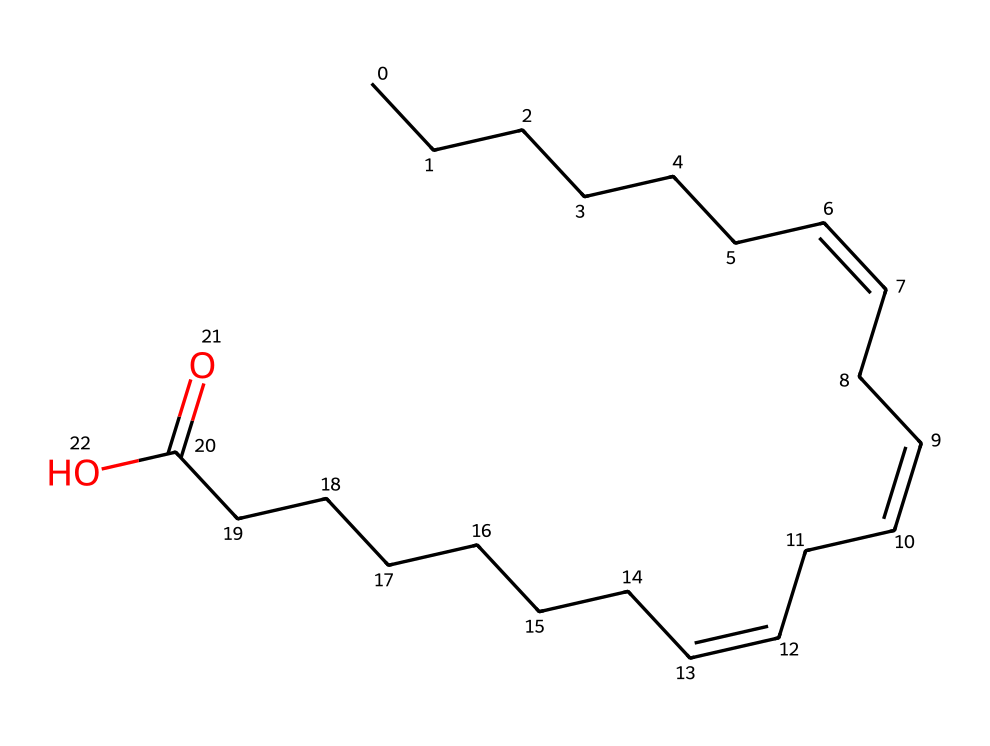how many carbon atoms are in this structure? By examining the SMILES representation, we count the number of carbon (C) atoms explicitly shown, including both the linear chain and any branching. The representation contains a total of 18 carbon atoms.
Answer: 18 how many double bonds are present? In the SMILES string, we identify the locations of double bonds which are indicated by the "/C=C\" segments. By analyzing the structure, we see there are three double bonds in the molecule.
Answer: 3 what is the functional group present in this compound? The presence of the -COOH group at the end of the structure signifies a carboxylic acid functional group. This can be identified from the "CCCCCCC(=O)O" portion of the SMILES, showing both a carbonyl (C=O) and hydroxyl (O-H) group.
Answer: carboxylic acid is this a saturated or unsaturated fatty acid? The presence of multiple carbon-carbon double bonds indicates that the fatty acid is unsaturated. The double bonds create kinks in the molecule, preventing tight packing, which is characteristic of unsaturated fatty acids.
Answer: unsaturated what type of isomerism can occur in this compound? Given the double bonds present in the structure, cis-trans isomerism (geometric isomerism) can occur due to the spatial arrangements possible around these double bonds, distinguishing between cis (same side) and trans (opposite side) configurations.
Answer: cis-trans isomerism how does the presence of double bonds affect the melting point of this compound? The presence of double bonds in the structure introduces kinks that prevent the molecules from packing closely together, which generally leads to a lower melting point compared to saturated fats with no double bonds.
Answer: lower melting point 